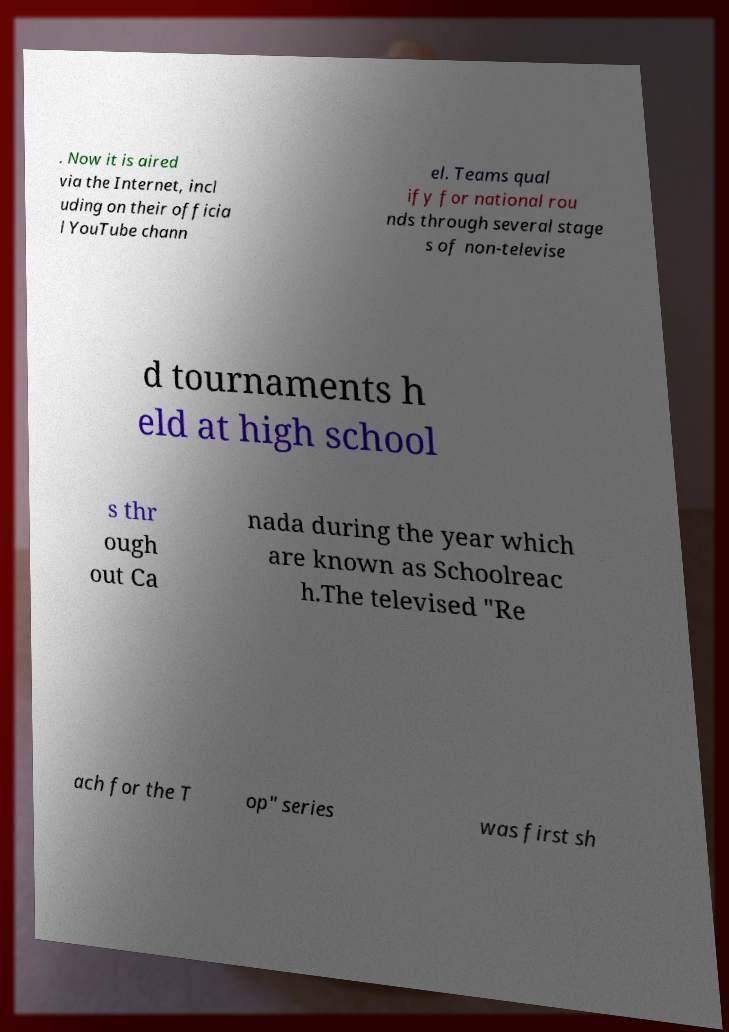Please identify and transcribe the text found in this image. . Now it is aired via the Internet, incl uding on their officia l YouTube chann el. Teams qual ify for national rou nds through several stage s of non-televise d tournaments h eld at high school s thr ough out Ca nada during the year which are known as Schoolreac h.The televised "Re ach for the T op" series was first sh 